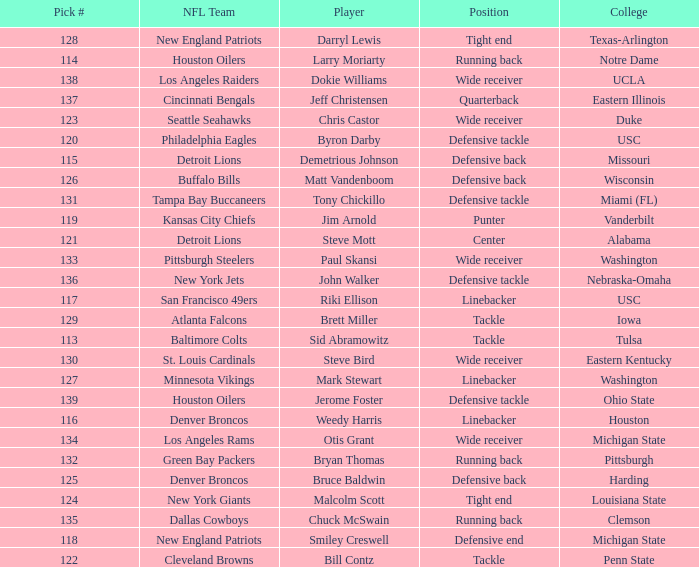Which player did the green bay packers pick? Bryan Thomas. 